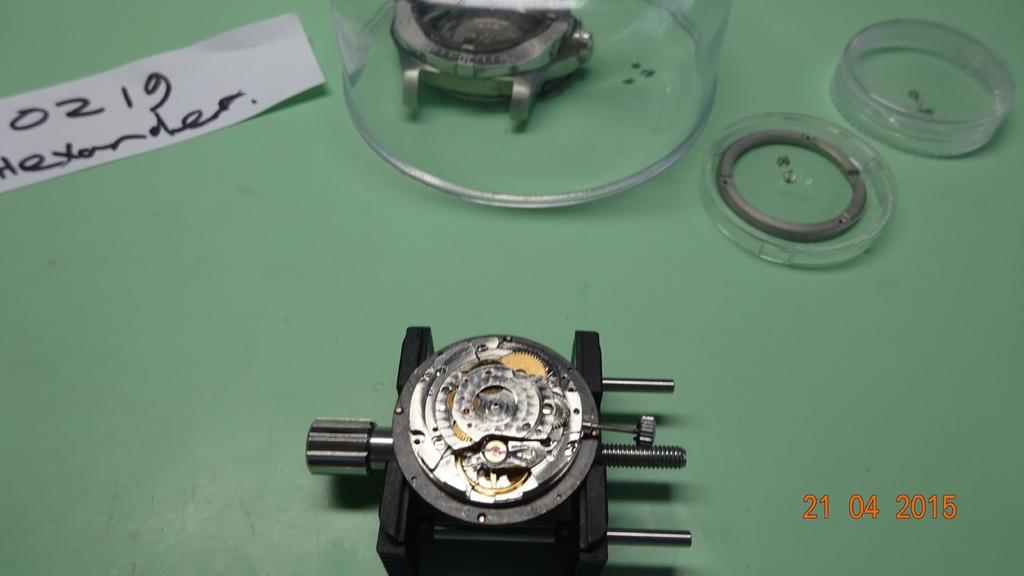<image>
Render a clear and concise summary of the photo. Pieces of a watch being repaired are in cases next to a piece of paper that says "0219 Alexander". 